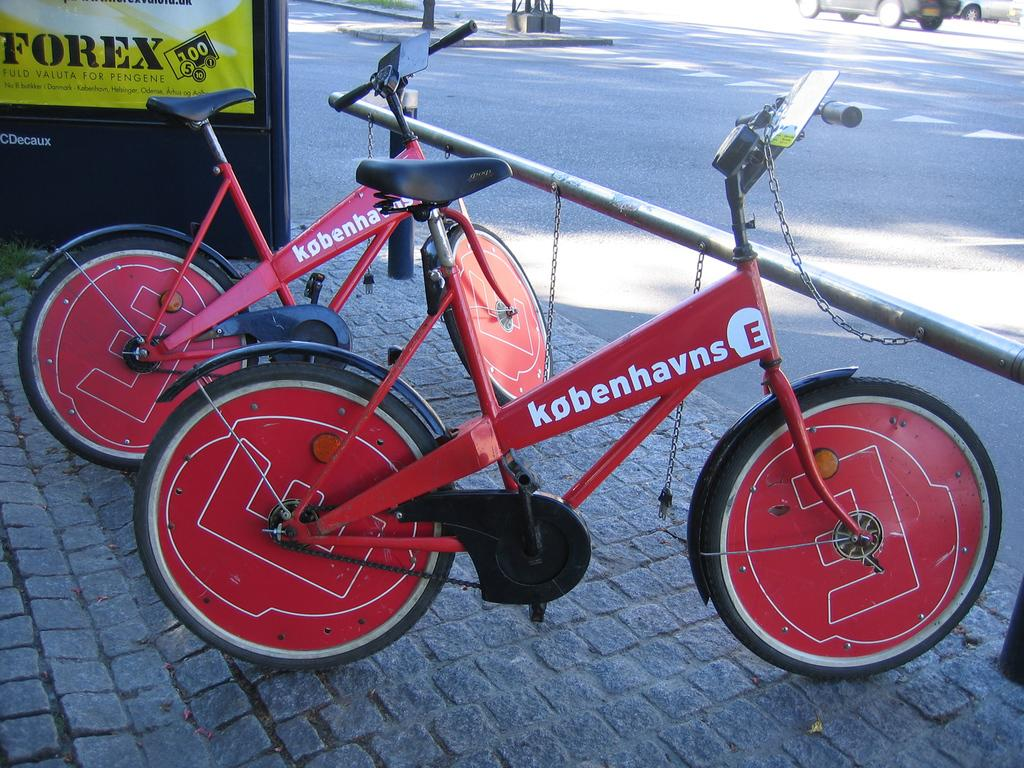How many cycles are present in the image? There are two cycles in the image. What is the position of the cycles in relation to each other? The cycles are tied to a rod with chains. What is located near the cycles in the image? There is a road beside the cycles. What is happening on the road in the image? A vehicle is moving on the road. What type of drum is being played in the image? There is no drum present in the image; it features two cycles tied to a rod with chains. Does the existence of the cycles in the image prove the existence of a parallel universe? The presence of cycles in the image does not prove the existence of a parallel universe; it simply shows two cycles tied to a rod with chains. 